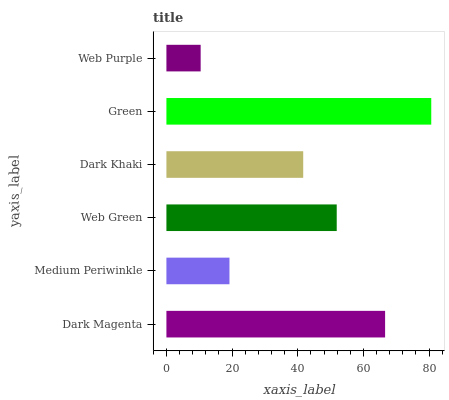Is Web Purple the minimum?
Answer yes or no. Yes. Is Green the maximum?
Answer yes or no. Yes. Is Medium Periwinkle the minimum?
Answer yes or no. No. Is Medium Periwinkle the maximum?
Answer yes or no. No. Is Dark Magenta greater than Medium Periwinkle?
Answer yes or no. Yes. Is Medium Periwinkle less than Dark Magenta?
Answer yes or no. Yes. Is Medium Periwinkle greater than Dark Magenta?
Answer yes or no. No. Is Dark Magenta less than Medium Periwinkle?
Answer yes or no. No. Is Web Green the high median?
Answer yes or no. Yes. Is Dark Khaki the low median?
Answer yes or no. Yes. Is Dark Khaki the high median?
Answer yes or no. No. Is Medium Periwinkle the low median?
Answer yes or no. No. 